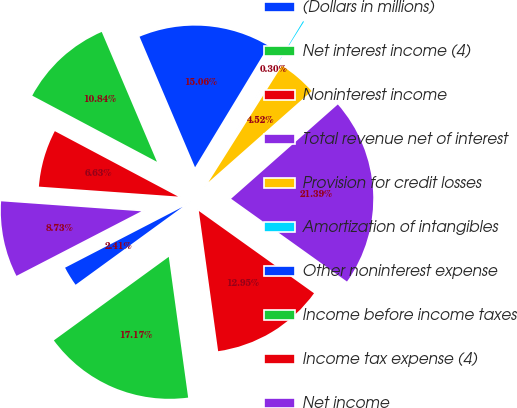<chart> <loc_0><loc_0><loc_500><loc_500><pie_chart><fcel>(Dollars in millions)<fcel>Net interest income (4)<fcel>Noninterest income<fcel>Total revenue net of interest<fcel>Provision for credit losses<fcel>Amortization of intangibles<fcel>Other noninterest expense<fcel>Income before income taxes<fcel>Income tax expense (4)<fcel>Net income<nl><fcel>2.41%<fcel>17.17%<fcel>12.95%<fcel>21.39%<fcel>4.52%<fcel>0.3%<fcel>15.06%<fcel>10.84%<fcel>6.63%<fcel>8.73%<nl></chart> 